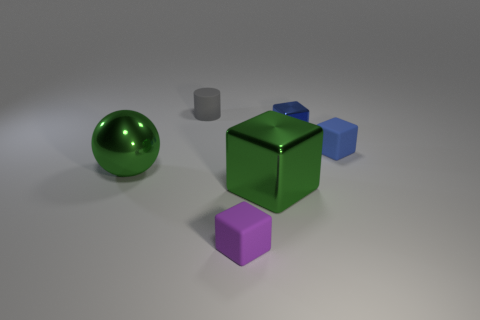What number of other objects are there of the same material as the tiny purple object?
Provide a short and direct response. 2. Does the gray matte cylinder have the same size as the shiny sphere?
Your answer should be very brief. No. How many objects are tiny matte cubes behind the purple block or large green spheres?
Ensure brevity in your answer.  2. What is the material of the big object to the right of the green object on the left side of the small gray cylinder?
Keep it short and to the point. Metal. Are there any large objects of the same shape as the tiny purple rubber thing?
Your answer should be compact. Yes. Do the cylinder and the green object right of the gray rubber cylinder have the same size?
Your response must be concise. No. How many things are either small objects in front of the big shiny block or cubes in front of the blue matte object?
Give a very brief answer. 2. Is the number of green objects that are behind the small cylinder greater than the number of red metal blocks?
Provide a short and direct response. No. What number of shiny spheres are the same size as the gray thing?
Provide a succinct answer. 0. Is the size of the rubber block behind the small purple matte thing the same as the rubber object that is on the left side of the purple cube?
Your answer should be very brief. Yes. 